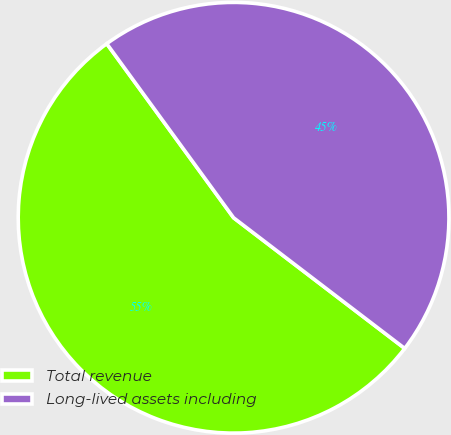Convert chart. <chart><loc_0><loc_0><loc_500><loc_500><pie_chart><fcel>Total revenue<fcel>Long-lived assets including<nl><fcel>54.6%<fcel>45.4%<nl></chart> 